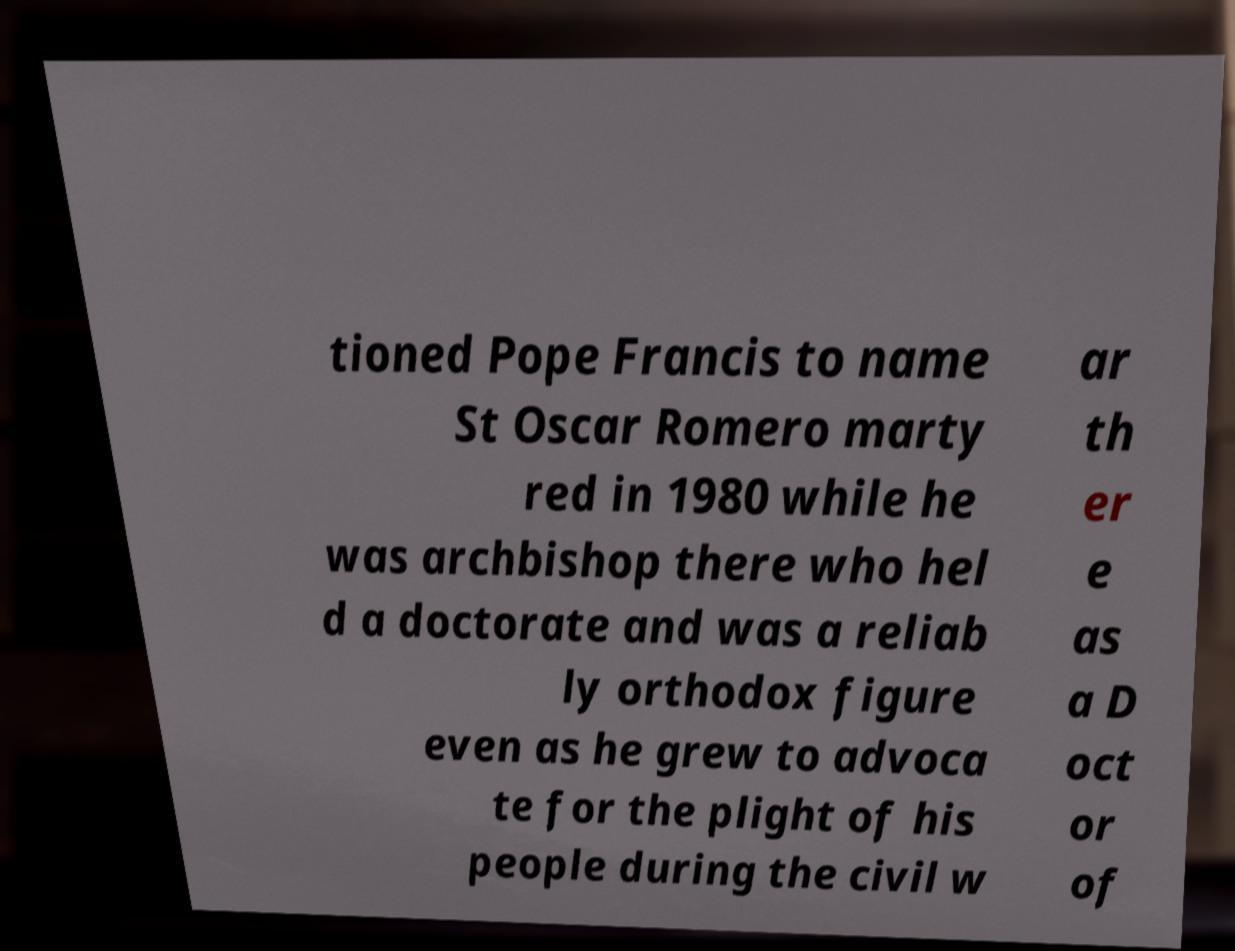Can you read and provide the text displayed in the image?This photo seems to have some interesting text. Can you extract and type it out for me? tioned Pope Francis to name St Oscar Romero marty red in 1980 while he was archbishop there who hel d a doctorate and was a reliab ly orthodox figure even as he grew to advoca te for the plight of his people during the civil w ar th er e as a D oct or of 